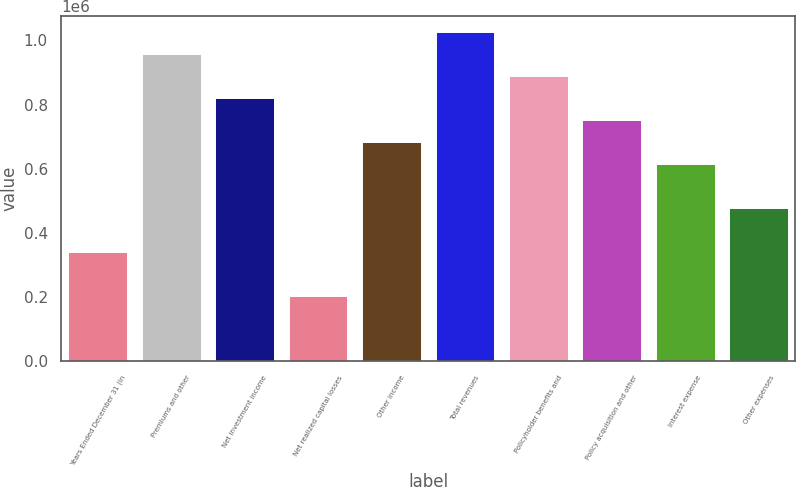<chart> <loc_0><loc_0><loc_500><loc_500><bar_chart><fcel>Years Ended December 31 (in<fcel>Premiums and other<fcel>Net investment income<fcel>Net realized capital losses<fcel>Other income<fcel>Total revenues<fcel>Policyholder benefits and<fcel>Policy acquisition and other<fcel>Interest expense<fcel>Other expenses<nl><fcel>341723<fcel>956819<fcel>820131<fcel>205035<fcel>683443<fcel>1.02516e+06<fcel>888475<fcel>751787<fcel>615099<fcel>478411<nl></chart> 